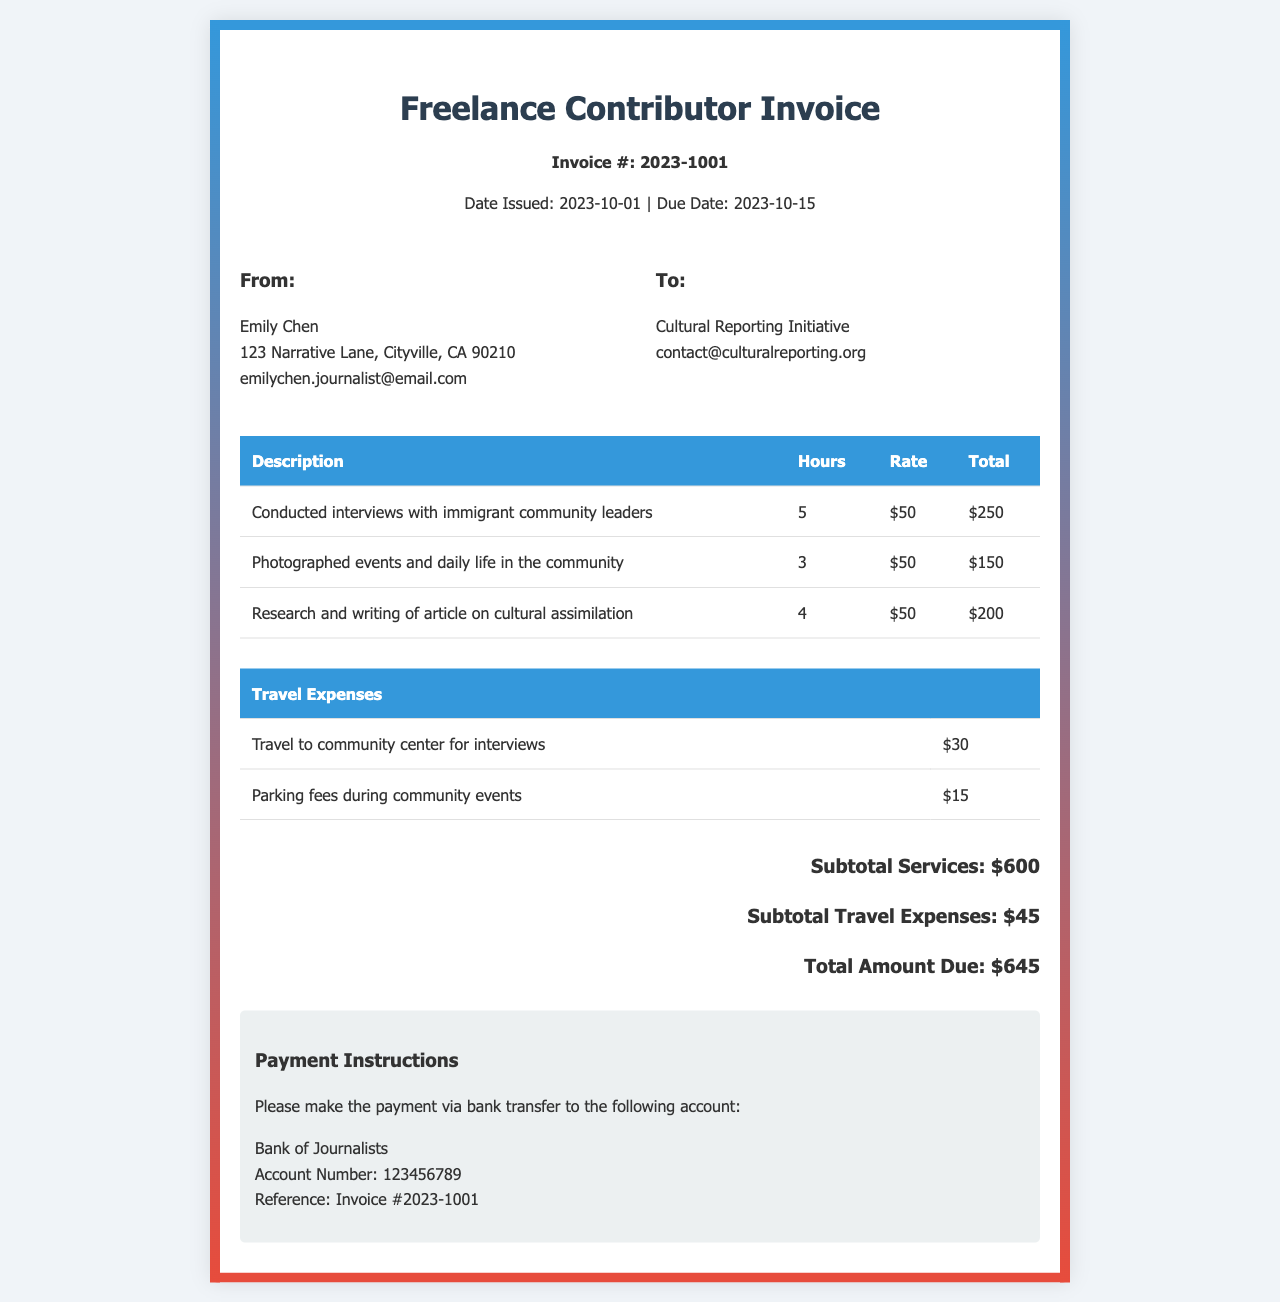What is the invoice number? The invoice number is listed at the top of the document under "Invoice #", which is 2023-1001.
Answer: 2023-1001 Who is the recipient of the invoice? The recipient's name and organization are stated under "To:" in the document, which is Cultural Reporting Initiative.
Answer: Cultural Reporting Initiative What is the total amount due? The total amount due is specified in the "Total Amount Due" section of the invoice, which sums up the services and travel expenses.
Answer: $645 How many hours were worked in total? The total hours can be calculated by adding the hours listed for each service rendered, which are 5, 3, and 4.
Answer: 12 What is the rate per hour? The rate per hour is mentioned in each line of the service descriptions, which is consistently $50.
Answer: $50 What travel expense is related to parking fees? The parking fee is listed under "Travel Expenses" as a separate line item associated with community events.
Answer: $15 How much was spent on conducting interviews? The amount spent on conducting interviews can be found in the service item for interviews, which shows the total cost for that service.
Answer: $250 What is the due date for the invoice? The due date is specified next to "Due Date:" in the document, which indicates when payment is required.
Answer: 2023-10-15 What is the name of the bank for payment? The bank name is stated in the "Payment Instructions" section for making the deposit.
Answer: Bank of Journalists 